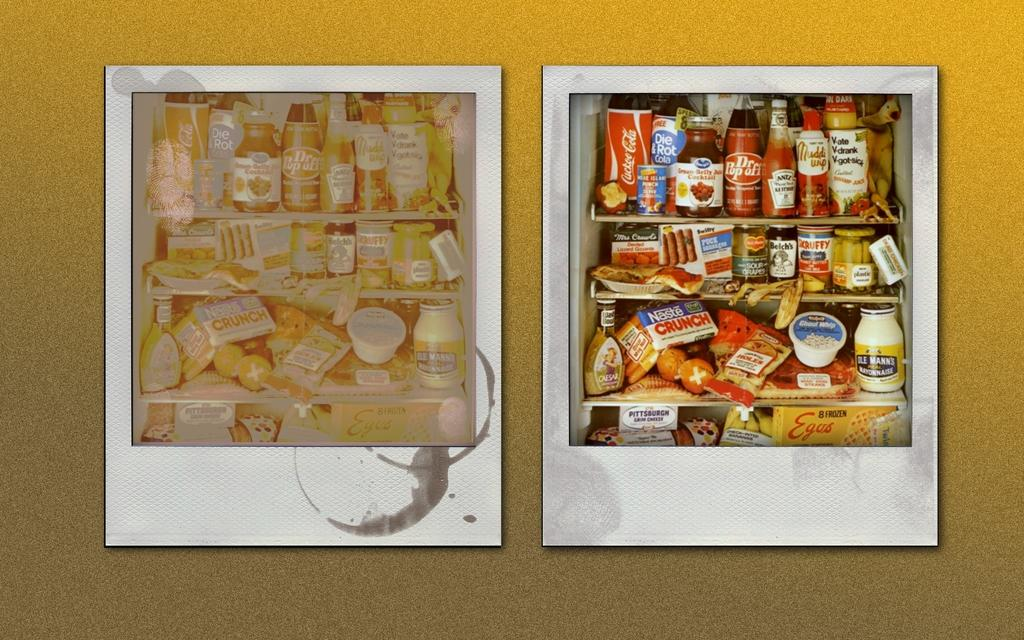Provide a one-sentence caption for the provided image. Two polaroid pictures side by side and one with a Dr. Popoff bottle. 